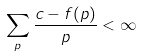<formula> <loc_0><loc_0><loc_500><loc_500>\sum _ { p } \frac { c - f ( p ) } { p } < \infty</formula> 